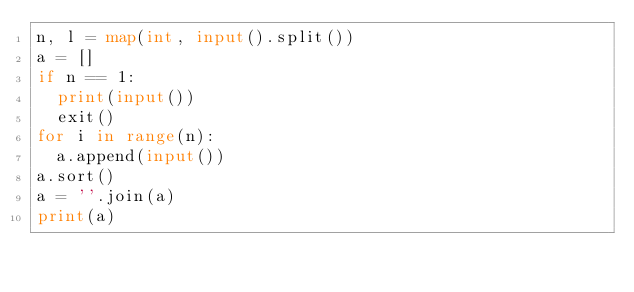Convert code to text. <code><loc_0><loc_0><loc_500><loc_500><_Python_>n, l = map(int, input().split())
a = []
if n == 1:
  print(input())
  exit()
for i in range(n):
  a.append(input())
a.sort()
a = ''.join(a)
print(a)</code> 